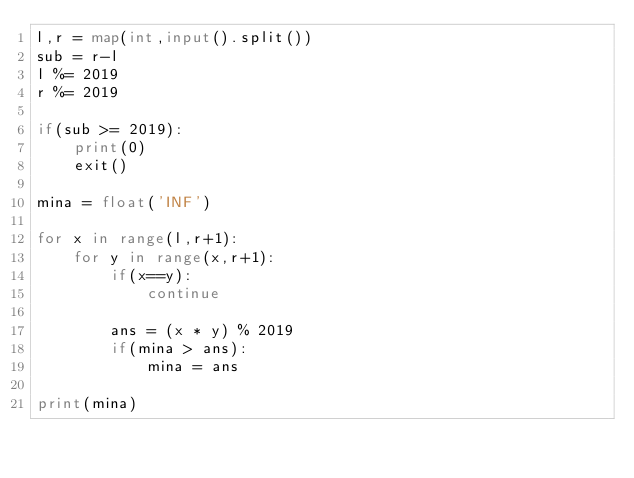<code> <loc_0><loc_0><loc_500><loc_500><_Python_>l,r = map(int,input().split())
sub = r-l
l %= 2019
r %= 2019

if(sub >= 2019):
    print(0)
    exit()

mina = float('INF')

for x in range(l,r+1):
    for y in range(x,r+1):
        if(x==y):
            continue
        
        ans = (x * y) % 2019
        if(mina > ans):
            mina = ans
       
print(mina)</code> 